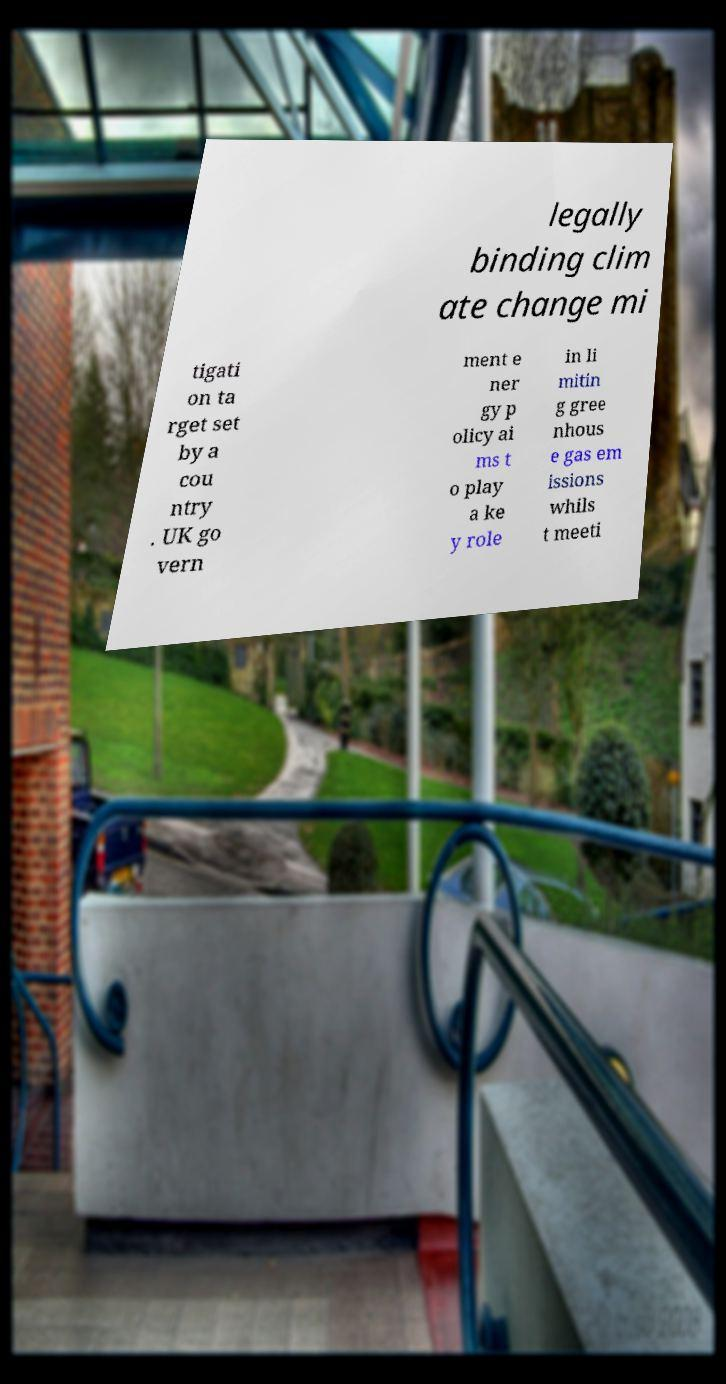Please identify and transcribe the text found in this image. legally binding clim ate change mi tigati on ta rget set by a cou ntry . UK go vern ment e ner gy p olicy ai ms t o play a ke y role in li mitin g gree nhous e gas em issions whils t meeti 